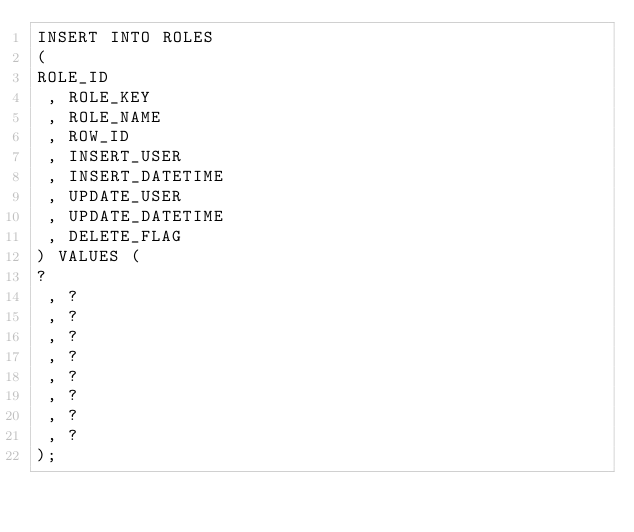<code> <loc_0><loc_0><loc_500><loc_500><_SQL_>INSERT INTO ROLES
( 
ROLE_ID
 , ROLE_KEY
 , ROLE_NAME
 , ROW_ID
 , INSERT_USER
 , INSERT_DATETIME
 , UPDATE_USER
 , UPDATE_DATETIME
 , DELETE_FLAG
) VALUES (
?
 , ?
 , ?
 , ?
 , ?
 , ?
 , ?
 , ?
 , ?
);
</code> 